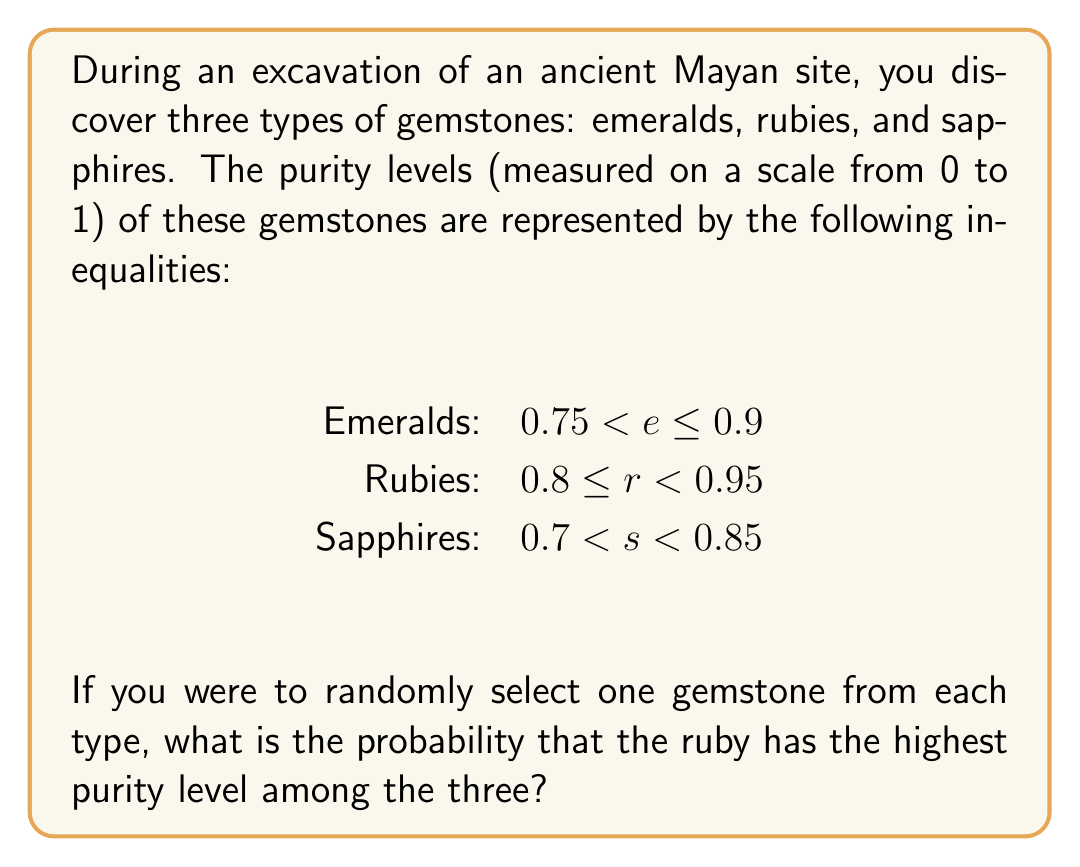Solve this math problem. To solve this problem, we need to consider the possible purity levels for each gemstone and determine the probability that a ruby has the highest purity.

Step 1: Analyze the given inequalities
Emeralds: $0.75 < e \leq 0.9$
Rubies: $0.8 \leq r < 0.95$
Sapphires: $0.7 < s < 0.85$

Step 2: Determine the conditions for a ruby to have the highest purity
For a ruby to have the highest purity, its purity level must be greater than both the emerald and sapphire purity levels.

Step 3: Find the minimum purity level for a ruby to be the highest
The ruby must have a purity level higher than 0.85 to be guaranteed higher than any sapphire.
The ruby must have a purity level higher than 0.9 to be guaranteed higher than any emerald.

Therefore, the minimum purity level for a ruby to be the highest is 0.9.

Step 4: Calculate the probability
The probability is the ratio of the favorable range to the total range for rubies.

Favorable range for rubies: $0.9 \leq r < 0.95$
Total range for rubies: $0.8 \leq r < 0.95$

Probability = $\frac{\text{Favorable range}}{\text{Total range}} = \frac{0.95 - 0.9}{0.95 - 0.8} = \frac{0.05}{0.15} = \frac{1}{3}$
Answer: $\frac{1}{3}$ 